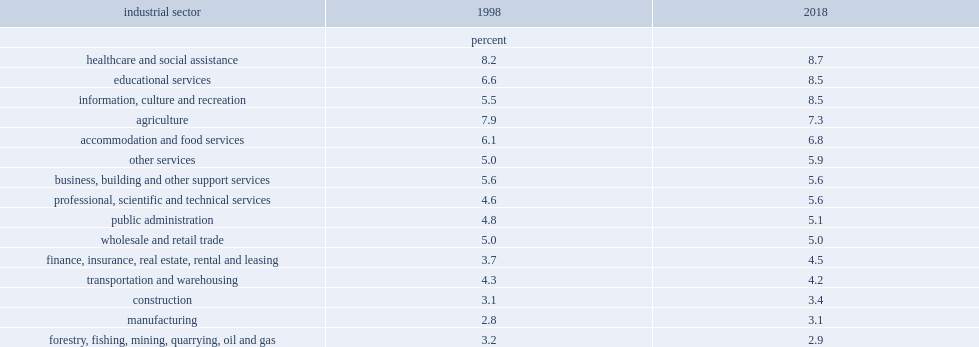In both 1998 and 2018, which industry sector the workers whose main job was in had the highest multiple jobholding rate? Healthcare and social assistance. Which industry sector had the lowest incidence of multiple jobholding among workers in 2018? Forestry, fishing, mining, quarrying, oil and gas. 